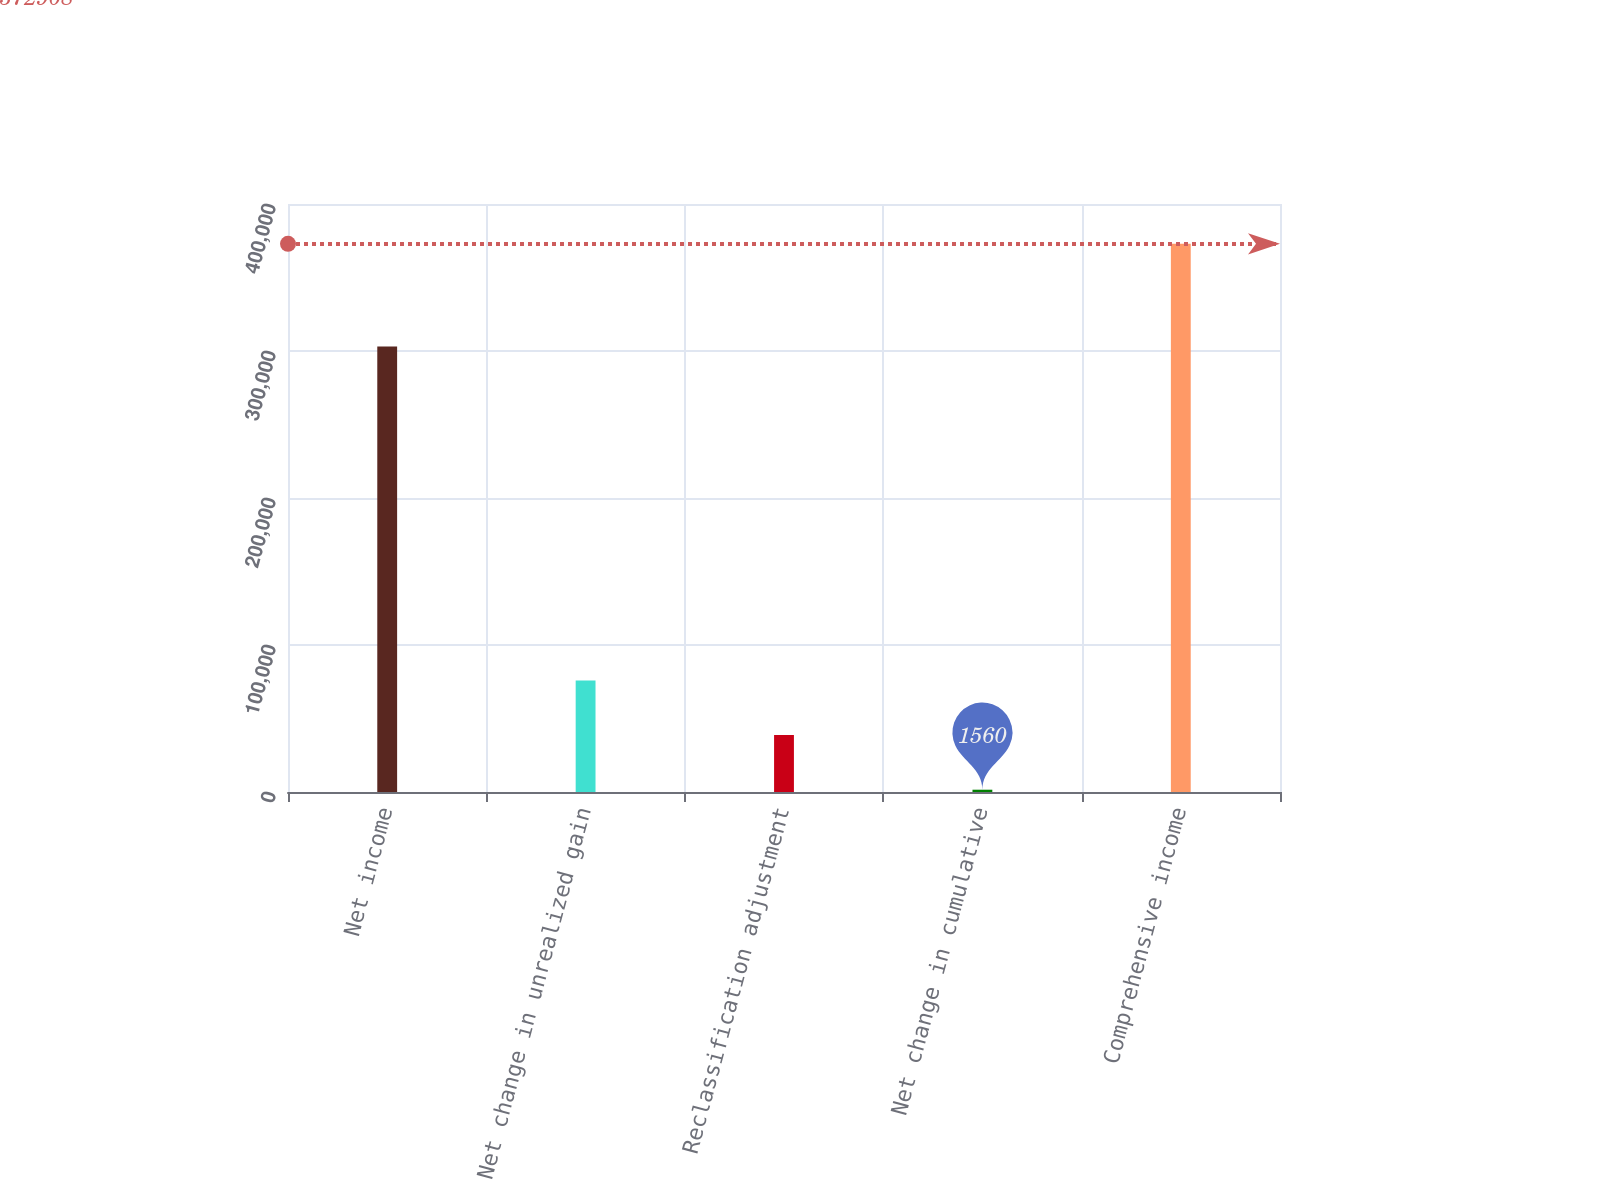Convert chart to OTSL. <chart><loc_0><loc_0><loc_500><loc_500><bar_chart><fcel>Net income<fcel>Net change in unrealized gain<fcel>Reclassification adjustment<fcel>Net change in cumulative<fcel>Comprehensive income<nl><fcel>302989<fcel>75829.6<fcel>38694.8<fcel>1560<fcel>372908<nl></chart> 